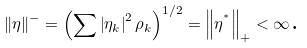Convert formula to latex. <formula><loc_0><loc_0><loc_500><loc_500>\left \| \eta \right \| ^ { - } = \left ( \sum \left | \eta _ { k } \right | ^ { 2 } \rho _ { k } \right ) ^ { 1 / 2 } = \left \| \eta ^ { ^ { * } } \right \| _ { + } < \infty \text {.}</formula> 